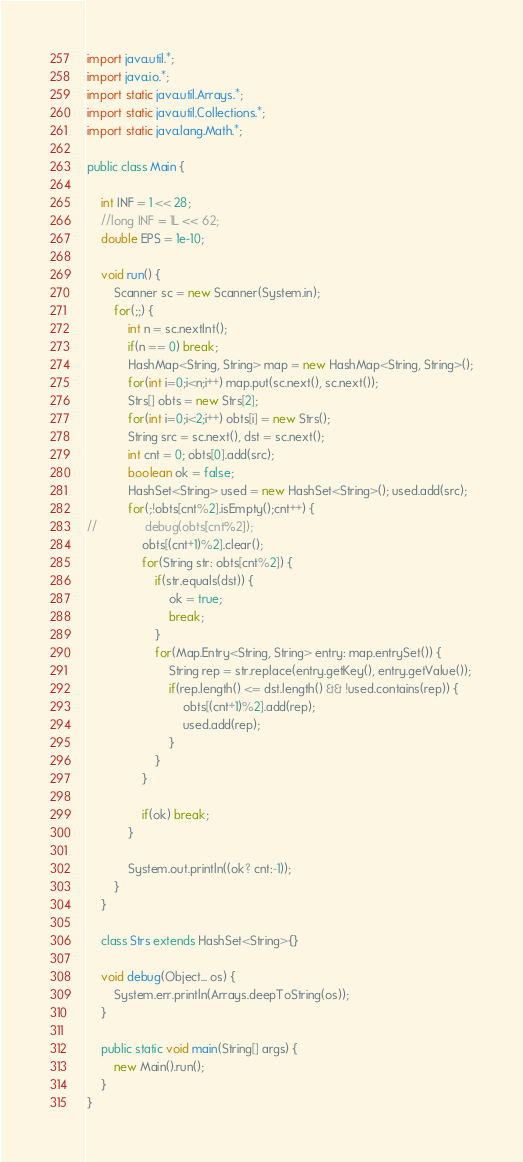Convert code to text. <code><loc_0><loc_0><loc_500><loc_500><_Java_>
import java.util.*;
import java.io.*;
import static java.util.Arrays.*;
import static java.util.Collections.*;
import static java.lang.Math.*;

public class Main {

	int INF = 1 << 28;
	//long INF = 1L << 62;
	double EPS = 1e-10;

	void run() {
		Scanner sc = new Scanner(System.in);
		for(;;) {
			int n = sc.nextInt();
			if(n == 0) break;
			HashMap<String, String> map = new HashMap<String, String>();
			for(int i=0;i<n;i++) map.put(sc.next(), sc.next());
			Strs[] obts = new Strs[2];
			for(int i=0;i<2;i++) obts[i] = new Strs();
			String src = sc.next(), dst = sc.next();
			int cnt = 0; obts[0].add(src);
			boolean ok = false;
			HashSet<String> used = new HashSet<String>(); used.add(src);
			for(;!obts[cnt%2].isEmpty();cnt++) {
//				debug(obts[cnt%2]);
				obts[(cnt+1)%2].clear();
				for(String str: obts[cnt%2]) {
					if(str.equals(dst)) {
						ok = true;
						break;
					}
					for(Map.Entry<String, String> entry: map.entrySet()) {
						String rep = str.replace(entry.getKey(), entry.getValue());
						if(rep.length() <= dst.length() && !used.contains(rep)) {
							obts[(cnt+1)%2].add(rep);
							used.add(rep);
						}
					}
				}
				
				if(ok) break;
			}
			
			System.out.println((ok? cnt:-1));
		}
	}
	
	class Strs extends HashSet<String>{}

	void debug(Object... os) {
		System.err.println(Arrays.deepToString(os));
	}

	public static void main(String[] args) {
		new Main().run();
	}
}</code> 